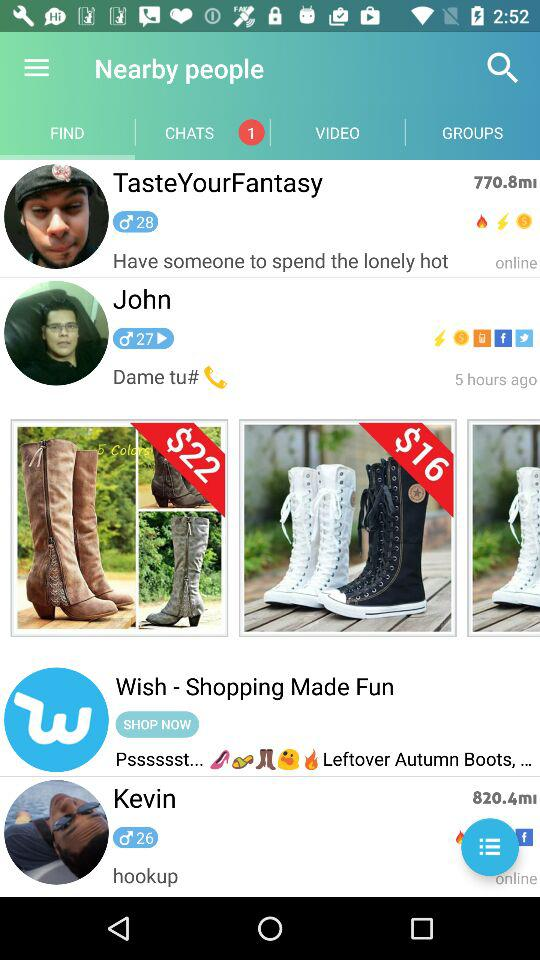Which user was online? The user who was online was John. 